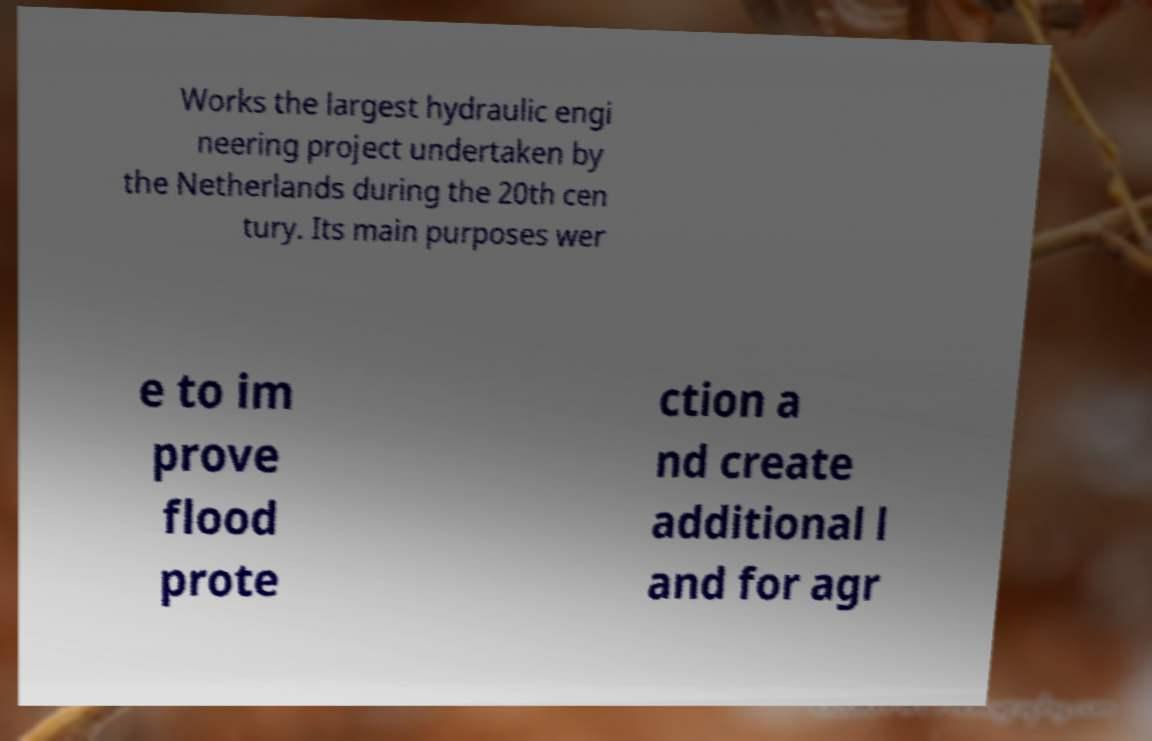Could you assist in decoding the text presented in this image and type it out clearly? Works the largest hydraulic engi neering project undertaken by the Netherlands during the 20th cen tury. Its main purposes wer e to im prove flood prote ction a nd create additional l and for agr 